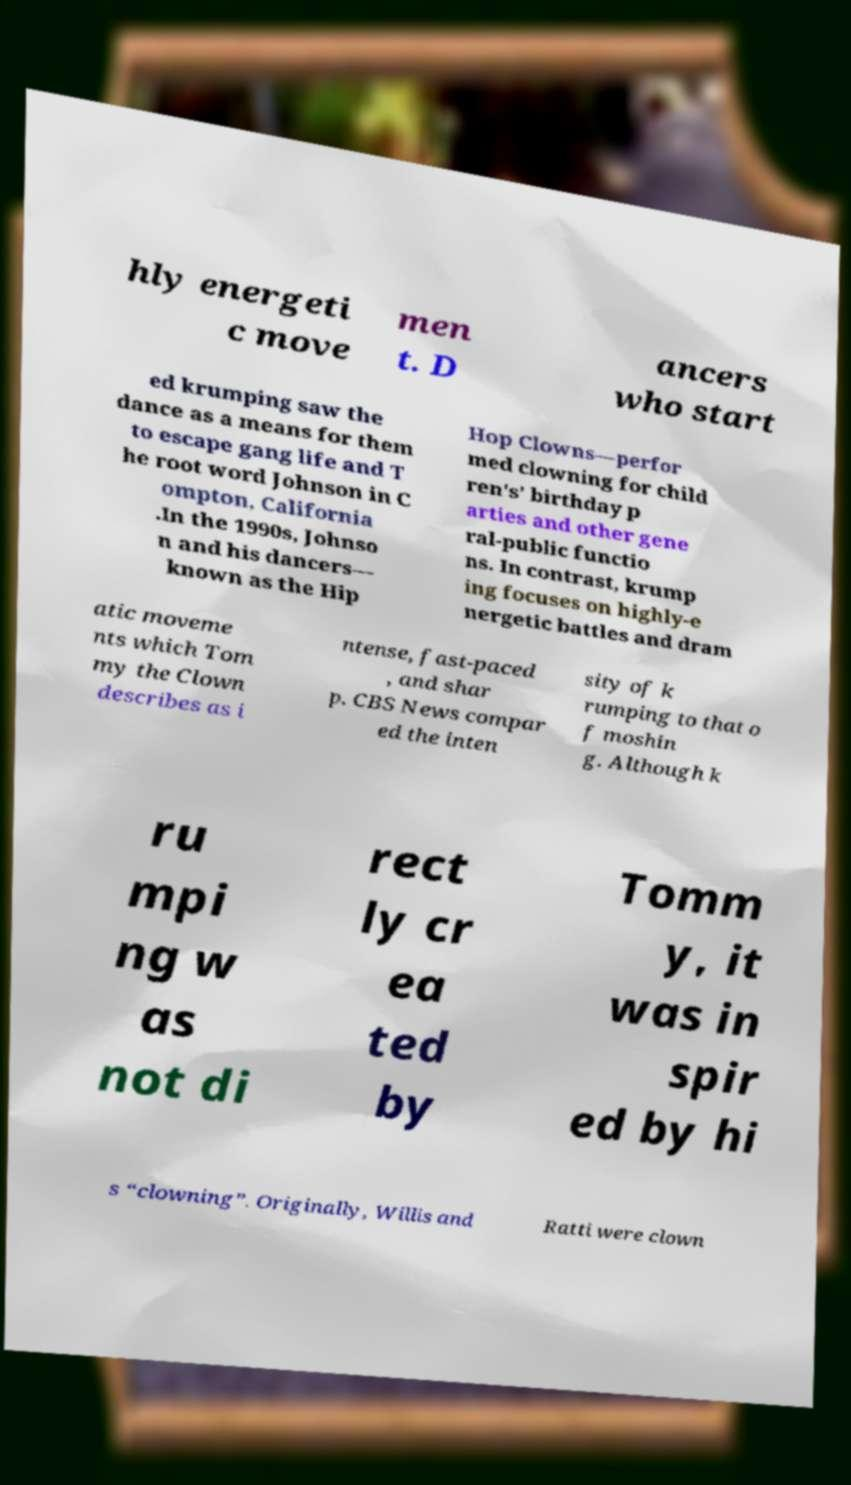What messages or text are displayed in this image? I need them in a readable, typed format. hly energeti c move men t. D ancers who start ed krumping saw the dance as a means for them to escape gang life and T he root word Johnson in C ompton, California .In the 1990s, Johnso n and his dancers— known as the Hip Hop Clowns—perfor med clowning for child ren's’ birthday p arties and other gene ral-public functio ns. In contrast, krump ing focuses on highly-e nergetic battles and dram atic moveme nts which Tom my the Clown describes as i ntense, fast-paced , and shar p. CBS News compar ed the inten sity of k rumping to that o f moshin g. Although k ru mpi ng w as not di rect ly cr ea ted by Tomm y, it was in spir ed by hi s “clowning”. Originally, Willis and Ratti were clown 